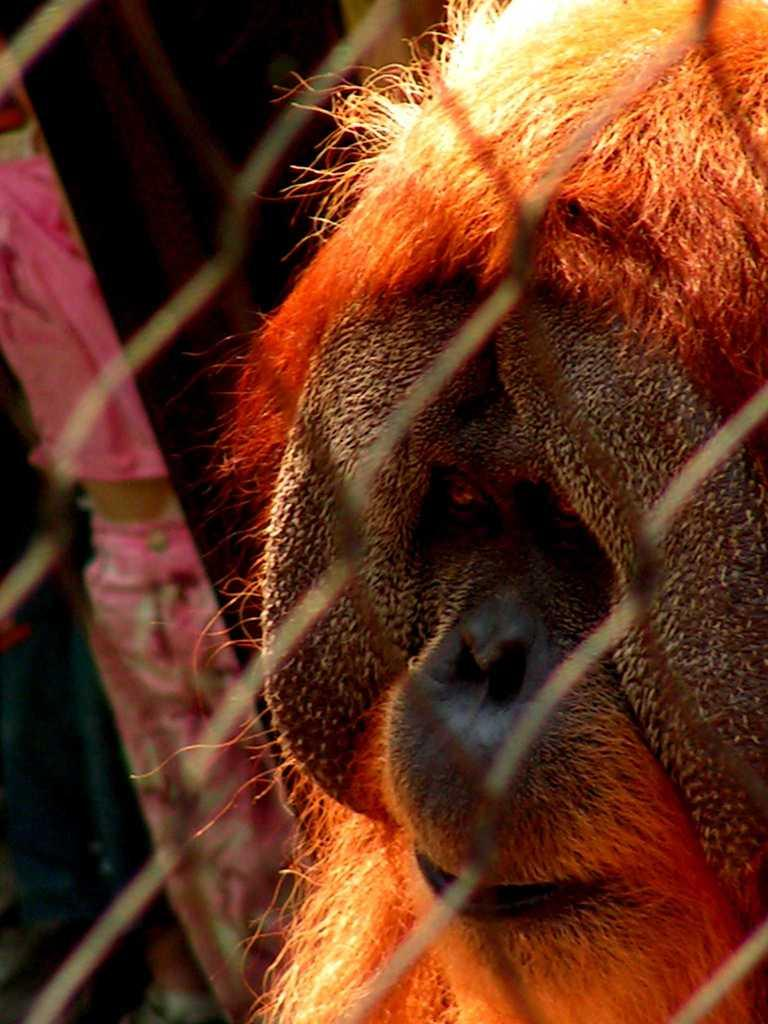What type of structure is visible in the image? There is a building in the image. What type of material is used for the fencing in the image? There is iron fencing in the image. Can you see a stream of rice flowing on the breakfast table in the image? There is no mention of a breakfast table or rice in the image. The image only features a building and iron fencing. 